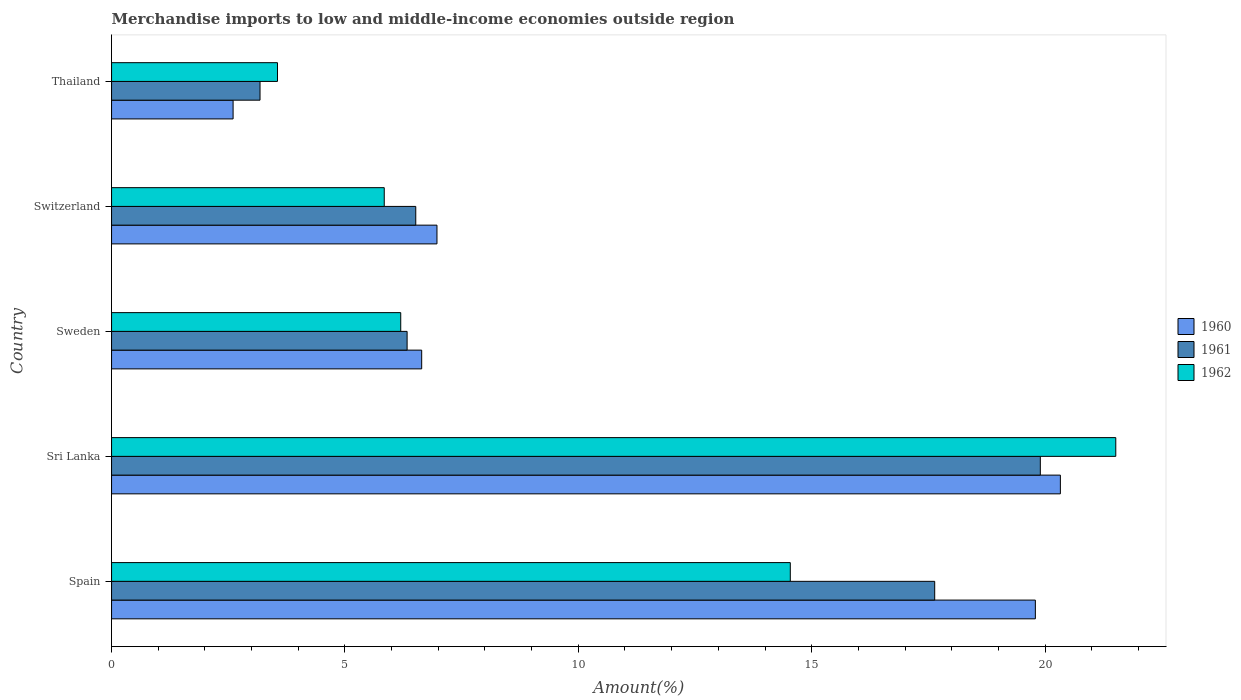How many different coloured bars are there?
Keep it short and to the point. 3. How many groups of bars are there?
Keep it short and to the point. 5. How many bars are there on the 2nd tick from the top?
Your answer should be very brief. 3. How many bars are there on the 4th tick from the bottom?
Offer a very short reply. 3. What is the label of the 1st group of bars from the top?
Keep it short and to the point. Thailand. In how many cases, is the number of bars for a given country not equal to the number of legend labels?
Ensure brevity in your answer.  0. What is the percentage of amount earned from merchandise imports in 1961 in Thailand?
Your answer should be very brief. 3.18. Across all countries, what is the maximum percentage of amount earned from merchandise imports in 1962?
Offer a very short reply. 21.51. Across all countries, what is the minimum percentage of amount earned from merchandise imports in 1962?
Ensure brevity in your answer.  3.55. In which country was the percentage of amount earned from merchandise imports in 1962 maximum?
Your response must be concise. Sri Lanka. In which country was the percentage of amount earned from merchandise imports in 1961 minimum?
Offer a terse response. Thailand. What is the total percentage of amount earned from merchandise imports in 1961 in the graph?
Offer a very short reply. 53.56. What is the difference between the percentage of amount earned from merchandise imports in 1961 in Spain and that in Thailand?
Offer a very short reply. 14.45. What is the difference between the percentage of amount earned from merchandise imports in 1960 in Thailand and the percentage of amount earned from merchandise imports in 1961 in Sweden?
Provide a short and direct response. -3.73. What is the average percentage of amount earned from merchandise imports in 1961 per country?
Provide a succinct answer. 10.71. What is the difference between the percentage of amount earned from merchandise imports in 1961 and percentage of amount earned from merchandise imports in 1960 in Sweden?
Offer a terse response. -0.31. What is the ratio of the percentage of amount earned from merchandise imports in 1962 in Sweden to that in Switzerland?
Provide a succinct answer. 1.06. Is the percentage of amount earned from merchandise imports in 1962 in Sweden less than that in Switzerland?
Offer a terse response. No. What is the difference between the highest and the second highest percentage of amount earned from merchandise imports in 1960?
Your answer should be compact. 0.54. What is the difference between the highest and the lowest percentage of amount earned from merchandise imports in 1962?
Provide a short and direct response. 17.96. Is the sum of the percentage of amount earned from merchandise imports in 1960 in Spain and Thailand greater than the maximum percentage of amount earned from merchandise imports in 1961 across all countries?
Your answer should be compact. Yes. What does the 1st bar from the top in Switzerland represents?
Offer a very short reply. 1962. What does the 1st bar from the bottom in Thailand represents?
Provide a succinct answer. 1960. Is it the case that in every country, the sum of the percentage of amount earned from merchandise imports in 1961 and percentage of amount earned from merchandise imports in 1962 is greater than the percentage of amount earned from merchandise imports in 1960?
Your response must be concise. Yes. What is the difference between two consecutive major ticks on the X-axis?
Make the answer very short. 5. How many legend labels are there?
Give a very brief answer. 3. What is the title of the graph?
Your response must be concise. Merchandise imports to low and middle-income economies outside region. Does "1981" appear as one of the legend labels in the graph?
Offer a terse response. No. What is the label or title of the X-axis?
Offer a very short reply. Amount(%). What is the label or title of the Y-axis?
Offer a very short reply. Country. What is the Amount(%) of 1960 in Spain?
Your response must be concise. 19.79. What is the Amount(%) in 1961 in Spain?
Provide a short and direct response. 17.64. What is the Amount(%) in 1962 in Spain?
Your answer should be compact. 14.54. What is the Amount(%) of 1960 in Sri Lanka?
Give a very brief answer. 20.33. What is the Amount(%) of 1961 in Sri Lanka?
Keep it short and to the point. 19.9. What is the Amount(%) in 1962 in Sri Lanka?
Ensure brevity in your answer.  21.51. What is the Amount(%) of 1960 in Sweden?
Ensure brevity in your answer.  6.64. What is the Amount(%) in 1961 in Sweden?
Make the answer very short. 6.33. What is the Amount(%) of 1962 in Sweden?
Offer a terse response. 6.2. What is the Amount(%) in 1960 in Switzerland?
Make the answer very short. 6.97. What is the Amount(%) in 1961 in Switzerland?
Your response must be concise. 6.52. What is the Amount(%) of 1962 in Switzerland?
Your response must be concise. 5.84. What is the Amount(%) in 1960 in Thailand?
Offer a very short reply. 2.6. What is the Amount(%) in 1961 in Thailand?
Keep it short and to the point. 3.18. What is the Amount(%) in 1962 in Thailand?
Your answer should be very brief. 3.55. Across all countries, what is the maximum Amount(%) in 1960?
Ensure brevity in your answer.  20.33. Across all countries, what is the maximum Amount(%) of 1961?
Your response must be concise. 19.9. Across all countries, what is the maximum Amount(%) of 1962?
Offer a terse response. 21.51. Across all countries, what is the minimum Amount(%) in 1960?
Give a very brief answer. 2.6. Across all countries, what is the minimum Amount(%) in 1961?
Give a very brief answer. 3.18. Across all countries, what is the minimum Amount(%) in 1962?
Provide a succinct answer. 3.55. What is the total Amount(%) of 1960 in the graph?
Your response must be concise. 56.34. What is the total Amount(%) of 1961 in the graph?
Provide a succinct answer. 53.56. What is the total Amount(%) of 1962 in the graph?
Your response must be concise. 51.65. What is the difference between the Amount(%) of 1960 in Spain and that in Sri Lanka?
Keep it short and to the point. -0.54. What is the difference between the Amount(%) of 1961 in Spain and that in Sri Lanka?
Your answer should be very brief. -2.26. What is the difference between the Amount(%) of 1962 in Spain and that in Sri Lanka?
Offer a very short reply. -6.97. What is the difference between the Amount(%) of 1960 in Spain and that in Sweden?
Ensure brevity in your answer.  13.15. What is the difference between the Amount(%) in 1961 in Spain and that in Sweden?
Make the answer very short. 11.3. What is the difference between the Amount(%) in 1962 in Spain and that in Sweden?
Give a very brief answer. 8.35. What is the difference between the Amount(%) in 1960 in Spain and that in Switzerland?
Give a very brief answer. 12.82. What is the difference between the Amount(%) in 1961 in Spain and that in Switzerland?
Your response must be concise. 11.12. What is the difference between the Amount(%) of 1962 in Spain and that in Switzerland?
Ensure brevity in your answer.  8.7. What is the difference between the Amount(%) in 1960 in Spain and that in Thailand?
Provide a succinct answer. 17.19. What is the difference between the Amount(%) of 1961 in Spain and that in Thailand?
Offer a terse response. 14.45. What is the difference between the Amount(%) of 1962 in Spain and that in Thailand?
Your answer should be compact. 10.99. What is the difference between the Amount(%) of 1960 in Sri Lanka and that in Sweden?
Your answer should be very brief. 13.68. What is the difference between the Amount(%) of 1961 in Sri Lanka and that in Sweden?
Provide a succinct answer. 13.57. What is the difference between the Amount(%) of 1962 in Sri Lanka and that in Sweden?
Provide a short and direct response. 15.32. What is the difference between the Amount(%) of 1960 in Sri Lanka and that in Switzerland?
Your answer should be compact. 13.36. What is the difference between the Amount(%) of 1961 in Sri Lanka and that in Switzerland?
Provide a succinct answer. 13.38. What is the difference between the Amount(%) in 1962 in Sri Lanka and that in Switzerland?
Your response must be concise. 15.67. What is the difference between the Amount(%) of 1960 in Sri Lanka and that in Thailand?
Keep it short and to the point. 17.72. What is the difference between the Amount(%) of 1961 in Sri Lanka and that in Thailand?
Make the answer very short. 16.72. What is the difference between the Amount(%) in 1962 in Sri Lanka and that in Thailand?
Your response must be concise. 17.96. What is the difference between the Amount(%) of 1960 in Sweden and that in Switzerland?
Offer a terse response. -0.33. What is the difference between the Amount(%) in 1961 in Sweden and that in Switzerland?
Offer a terse response. -0.19. What is the difference between the Amount(%) in 1962 in Sweden and that in Switzerland?
Offer a very short reply. 0.35. What is the difference between the Amount(%) of 1960 in Sweden and that in Thailand?
Ensure brevity in your answer.  4.04. What is the difference between the Amount(%) in 1961 in Sweden and that in Thailand?
Provide a short and direct response. 3.15. What is the difference between the Amount(%) of 1962 in Sweden and that in Thailand?
Give a very brief answer. 2.64. What is the difference between the Amount(%) in 1960 in Switzerland and that in Thailand?
Keep it short and to the point. 4.37. What is the difference between the Amount(%) in 1961 in Switzerland and that in Thailand?
Ensure brevity in your answer.  3.34. What is the difference between the Amount(%) in 1962 in Switzerland and that in Thailand?
Give a very brief answer. 2.29. What is the difference between the Amount(%) in 1960 in Spain and the Amount(%) in 1961 in Sri Lanka?
Your answer should be compact. -0.11. What is the difference between the Amount(%) in 1960 in Spain and the Amount(%) in 1962 in Sri Lanka?
Your response must be concise. -1.72. What is the difference between the Amount(%) of 1961 in Spain and the Amount(%) of 1962 in Sri Lanka?
Make the answer very short. -3.88. What is the difference between the Amount(%) of 1960 in Spain and the Amount(%) of 1961 in Sweden?
Offer a terse response. 13.46. What is the difference between the Amount(%) of 1960 in Spain and the Amount(%) of 1962 in Sweden?
Offer a terse response. 13.6. What is the difference between the Amount(%) in 1961 in Spain and the Amount(%) in 1962 in Sweden?
Offer a very short reply. 11.44. What is the difference between the Amount(%) in 1960 in Spain and the Amount(%) in 1961 in Switzerland?
Ensure brevity in your answer.  13.27. What is the difference between the Amount(%) in 1960 in Spain and the Amount(%) in 1962 in Switzerland?
Your answer should be very brief. 13.95. What is the difference between the Amount(%) in 1961 in Spain and the Amount(%) in 1962 in Switzerland?
Provide a short and direct response. 11.79. What is the difference between the Amount(%) of 1960 in Spain and the Amount(%) of 1961 in Thailand?
Your answer should be very brief. 16.61. What is the difference between the Amount(%) in 1960 in Spain and the Amount(%) in 1962 in Thailand?
Your response must be concise. 16.24. What is the difference between the Amount(%) of 1961 in Spain and the Amount(%) of 1962 in Thailand?
Ensure brevity in your answer.  14.08. What is the difference between the Amount(%) of 1960 in Sri Lanka and the Amount(%) of 1961 in Sweden?
Give a very brief answer. 14. What is the difference between the Amount(%) in 1960 in Sri Lanka and the Amount(%) in 1962 in Sweden?
Offer a terse response. 14.13. What is the difference between the Amount(%) in 1961 in Sri Lanka and the Amount(%) in 1962 in Sweden?
Make the answer very short. 13.7. What is the difference between the Amount(%) of 1960 in Sri Lanka and the Amount(%) of 1961 in Switzerland?
Your response must be concise. 13.81. What is the difference between the Amount(%) in 1960 in Sri Lanka and the Amount(%) in 1962 in Switzerland?
Your answer should be compact. 14.49. What is the difference between the Amount(%) in 1961 in Sri Lanka and the Amount(%) in 1962 in Switzerland?
Provide a short and direct response. 14.06. What is the difference between the Amount(%) in 1960 in Sri Lanka and the Amount(%) in 1961 in Thailand?
Ensure brevity in your answer.  17.15. What is the difference between the Amount(%) in 1960 in Sri Lanka and the Amount(%) in 1962 in Thailand?
Your response must be concise. 16.77. What is the difference between the Amount(%) in 1961 in Sri Lanka and the Amount(%) in 1962 in Thailand?
Your response must be concise. 16.34. What is the difference between the Amount(%) of 1960 in Sweden and the Amount(%) of 1961 in Switzerland?
Make the answer very short. 0.13. What is the difference between the Amount(%) of 1960 in Sweden and the Amount(%) of 1962 in Switzerland?
Offer a terse response. 0.8. What is the difference between the Amount(%) of 1961 in Sweden and the Amount(%) of 1962 in Switzerland?
Offer a terse response. 0.49. What is the difference between the Amount(%) of 1960 in Sweden and the Amount(%) of 1961 in Thailand?
Your response must be concise. 3.46. What is the difference between the Amount(%) of 1960 in Sweden and the Amount(%) of 1962 in Thailand?
Your answer should be very brief. 3.09. What is the difference between the Amount(%) in 1961 in Sweden and the Amount(%) in 1962 in Thailand?
Keep it short and to the point. 2.78. What is the difference between the Amount(%) in 1960 in Switzerland and the Amount(%) in 1961 in Thailand?
Offer a very short reply. 3.79. What is the difference between the Amount(%) in 1960 in Switzerland and the Amount(%) in 1962 in Thailand?
Offer a terse response. 3.42. What is the difference between the Amount(%) of 1961 in Switzerland and the Amount(%) of 1962 in Thailand?
Your answer should be compact. 2.96. What is the average Amount(%) in 1960 per country?
Your response must be concise. 11.27. What is the average Amount(%) of 1961 per country?
Provide a short and direct response. 10.71. What is the average Amount(%) of 1962 per country?
Give a very brief answer. 10.33. What is the difference between the Amount(%) in 1960 and Amount(%) in 1961 in Spain?
Provide a short and direct response. 2.16. What is the difference between the Amount(%) in 1960 and Amount(%) in 1962 in Spain?
Offer a terse response. 5.25. What is the difference between the Amount(%) in 1961 and Amount(%) in 1962 in Spain?
Ensure brevity in your answer.  3.09. What is the difference between the Amount(%) of 1960 and Amount(%) of 1961 in Sri Lanka?
Your answer should be compact. 0.43. What is the difference between the Amount(%) of 1960 and Amount(%) of 1962 in Sri Lanka?
Your response must be concise. -1.19. What is the difference between the Amount(%) in 1961 and Amount(%) in 1962 in Sri Lanka?
Offer a terse response. -1.62. What is the difference between the Amount(%) in 1960 and Amount(%) in 1961 in Sweden?
Offer a terse response. 0.31. What is the difference between the Amount(%) of 1960 and Amount(%) of 1962 in Sweden?
Give a very brief answer. 0.45. What is the difference between the Amount(%) in 1961 and Amount(%) in 1962 in Sweden?
Your answer should be compact. 0.14. What is the difference between the Amount(%) in 1960 and Amount(%) in 1961 in Switzerland?
Your answer should be compact. 0.45. What is the difference between the Amount(%) of 1960 and Amount(%) of 1962 in Switzerland?
Your answer should be very brief. 1.13. What is the difference between the Amount(%) in 1961 and Amount(%) in 1962 in Switzerland?
Provide a succinct answer. 0.68. What is the difference between the Amount(%) of 1960 and Amount(%) of 1961 in Thailand?
Your answer should be compact. -0.58. What is the difference between the Amount(%) in 1960 and Amount(%) in 1962 in Thailand?
Make the answer very short. -0.95. What is the difference between the Amount(%) of 1961 and Amount(%) of 1962 in Thailand?
Provide a short and direct response. -0.37. What is the ratio of the Amount(%) in 1960 in Spain to that in Sri Lanka?
Give a very brief answer. 0.97. What is the ratio of the Amount(%) in 1961 in Spain to that in Sri Lanka?
Your answer should be compact. 0.89. What is the ratio of the Amount(%) of 1962 in Spain to that in Sri Lanka?
Keep it short and to the point. 0.68. What is the ratio of the Amount(%) in 1960 in Spain to that in Sweden?
Offer a terse response. 2.98. What is the ratio of the Amount(%) in 1961 in Spain to that in Sweden?
Your answer should be very brief. 2.79. What is the ratio of the Amount(%) of 1962 in Spain to that in Sweden?
Your answer should be compact. 2.35. What is the ratio of the Amount(%) in 1960 in Spain to that in Switzerland?
Make the answer very short. 2.84. What is the ratio of the Amount(%) in 1961 in Spain to that in Switzerland?
Give a very brief answer. 2.71. What is the ratio of the Amount(%) in 1962 in Spain to that in Switzerland?
Offer a terse response. 2.49. What is the ratio of the Amount(%) of 1960 in Spain to that in Thailand?
Provide a short and direct response. 7.6. What is the ratio of the Amount(%) of 1961 in Spain to that in Thailand?
Offer a terse response. 5.54. What is the ratio of the Amount(%) in 1962 in Spain to that in Thailand?
Make the answer very short. 4.09. What is the ratio of the Amount(%) in 1960 in Sri Lanka to that in Sweden?
Make the answer very short. 3.06. What is the ratio of the Amount(%) in 1961 in Sri Lanka to that in Sweden?
Your answer should be compact. 3.14. What is the ratio of the Amount(%) in 1962 in Sri Lanka to that in Sweden?
Provide a succinct answer. 3.47. What is the ratio of the Amount(%) in 1960 in Sri Lanka to that in Switzerland?
Make the answer very short. 2.92. What is the ratio of the Amount(%) of 1961 in Sri Lanka to that in Switzerland?
Offer a very short reply. 3.05. What is the ratio of the Amount(%) in 1962 in Sri Lanka to that in Switzerland?
Make the answer very short. 3.68. What is the ratio of the Amount(%) of 1960 in Sri Lanka to that in Thailand?
Provide a short and direct response. 7.81. What is the ratio of the Amount(%) in 1961 in Sri Lanka to that in Thailand?
Offer a terse response. 6.26. What is the ratio of the Amount(%) in 1962 in Sri Lanka to that in Thailand?
Your answer should be compact. 6.05. What is the ratio of the Amount(%) in 1960 in Sweden to that in Switzerland?
Provide a succinct answer. 0.95. What is the ratio of the Amount(%) in 1961 in Sweden to that in Switzerland?
Offer a very short reply. 0.97. What is the ratio of the Amount(%) of 1962 in Sweden to that in Switzerland?
Provide a succinct answer. 1.06. What is the ratio of the Amount(%) in 1960 in Sweden to that in Thailand?
Provide a short and direct response. 2.55. What is the ratio of the Amount(%) of 1961 in Sweden to that in Thailand?
Give a very brief answer. 1.99. What is the ratio of the Amount(%) of 1962 in Sweden to that in Thailand?
Provide a succinct answer. 1.74. What is the ratio of the Amount(%) of 1960 in Switzerland to that in Thailand?
Your answer should be very brief. 2.68. What is the ratio of the Amount(%) in 1961 in Switzerland to that in Thailand?
Your answer should be compact. 2.05. What is the ratio of the Amount(%) in 1962 in Switzerland to that in Thailand?
Ensure brevity in your answer.  1.64. What is the difference between the highest and the second highest Amount(%) of 1960?
Give a very brief answer. 0.54. What is the difference between the highest and the second highest Amount(%) of 1961?
Make the answer very short. 2.26. What is the difference between the highest and the second highest Amount(%) in 1962?
Your answer should be very brief. 6.97. What is the difference between the highest and the lowest Amount(%) of 1960?
Give a very brief answer. 17.72. What is the difference between the highest and the lowest Amount(%) in 1961?
Ensure brevity in your answer.  16.72. What is the difference between the highest and the lowest Amount(%) in 1962?
Provide a succinct answer. 17.96. 